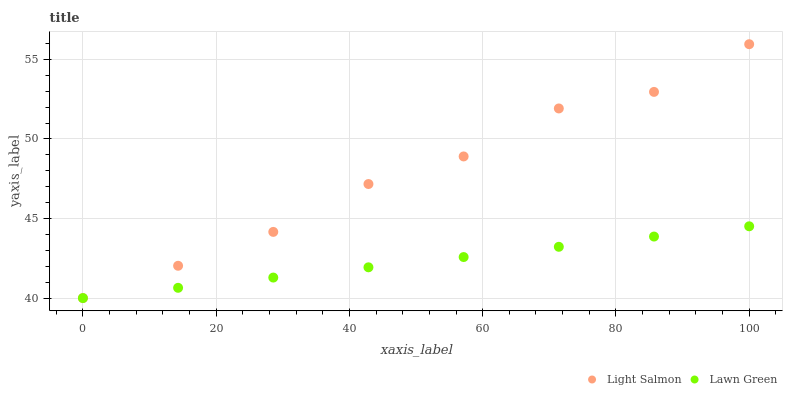Does Lawn Green have the minimum area under the curve?
Answer yes or no. Yes. Does Light Salmon have the maximum area under the curve?
Answer yes or no. Yes. Does Light Salmon have the minimum area under the curve?
Answer yes or no. No. Is Lawn Green the smoothest?
Answer yes or no. Yes. Is Light Salmon the roughest?
Answer yes or no. Yes. Is Light Salmon the smoothest?
Answer yes or no. No. Does Lawn Green have the lowest value?
Answer yes or no. Yes. Does Light Salmon have the highest value?
Answer yes or no. Yes. Does Light Salmon intersect Lawn Green?
Answer yes or no. Yes. Is Light Salmon less than Lawn Green?
Answer yes or no. No. Is Light Salmon greater than Lawn Green?
Answer yes or no. No. 